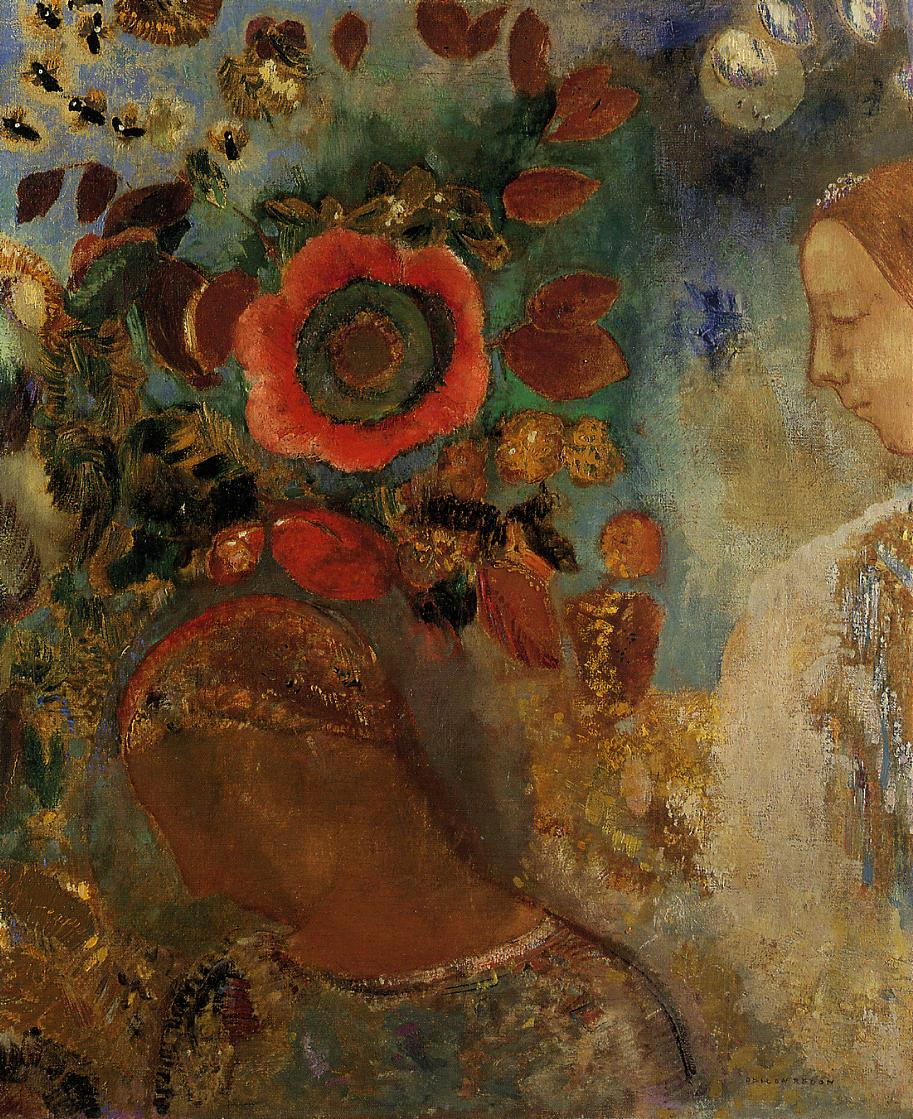Imagine this scene is part of a larger story or narrative. What could that story be? In a mystical garden where nature and spirits intertwine seamlessly, lives a woman named Elara, a guardian of the sacred blooms. With each sunrise, she engages in deep meditation, connecting with the essence of the vibrant flowers around her. The large red flower, a symbol of her heart, radiates with the energy she receives and dispenses throughout the garden. Each brushstroke in this impressionistic scene represents the whispers of ancient trees and the songs of invisible creatures that guide Elara in her guardianship. The painting captures a fleeting moment of harmony and silent communication between Elara and the divine forces of nature, reflecting her serene yet powerful presence in this enchanted world. 